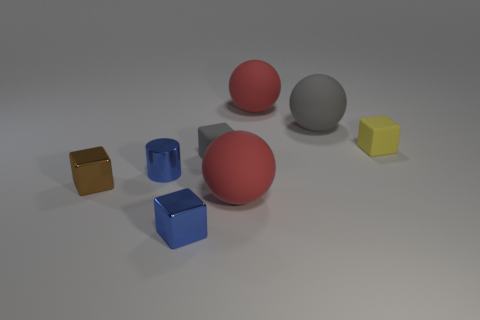Add 1 blue objects. How many objects exist? 9 Subtract all balls. How many objects are left? 5 Add 4 matte objects. How many matte objects are left? 9 Add 4 large gray spheres. How many large gray spheres exist? 5 Subtract 0 brown balls. How many objects are left? 8 Subtract all gray cubes. Subtract all tiny blue cylinders. How many objects are left? 6 